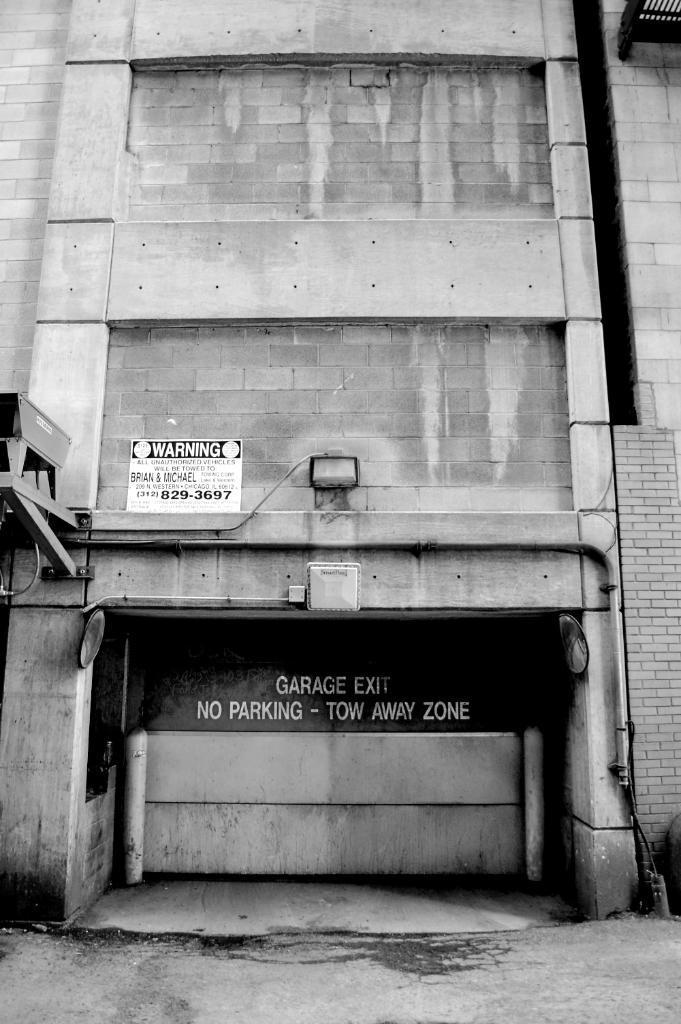Could you give a brief overview of what you see in this image? This is a black and white image in this image there is one building, and on the building there are some boards and on the board there is some text. At the bottom there is a road. 